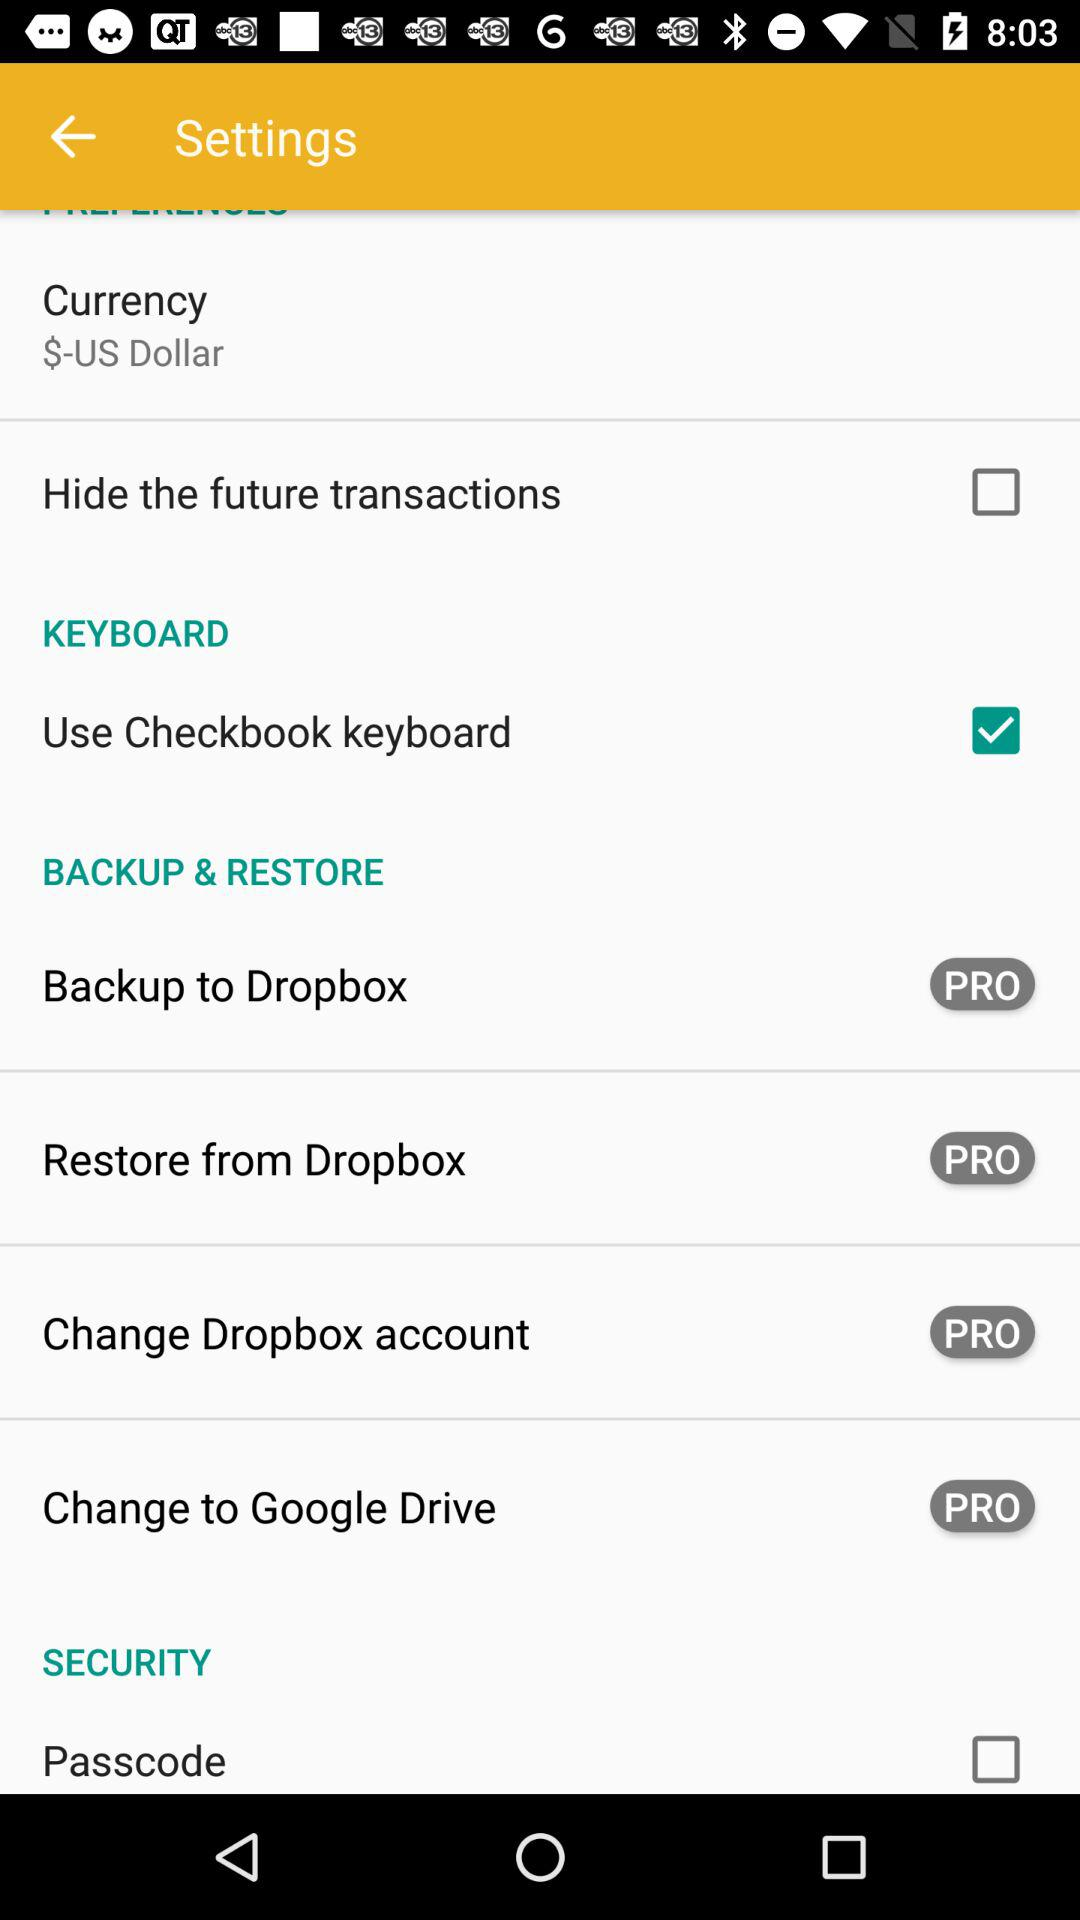What is the status of "Passcode"? The status is "off". 